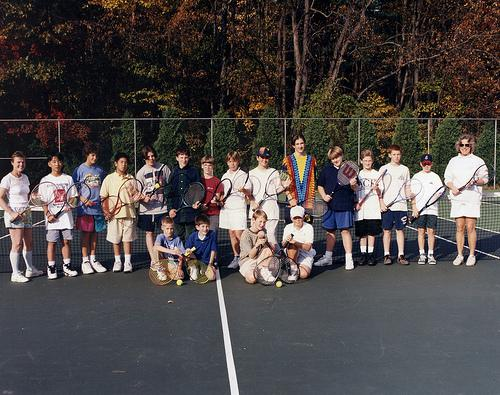Question: where are the kids?
Choices:
A. At the park.
B. In the backyard.
C. At the beach.
D. In the tennis court.
Answer with the letter. Answer: D Question: what is behind the fence?
Choices:
A. Trees.
B. House.
C. Swimming pool.
D. Garden.
Answer with the letter. Answer: A Question: why the kids holding rackets?
Choices:
A. To play racquetball.
B. To play badminton.
C. To play tennis.
D. To play squash.
Answer with the letter. Answer: C Question: who are holding the rackets?
Choices:
A. The players.
B. The kids.
C. The salespeople.
D. The coaches.
Answer with the letter. Answer: B 